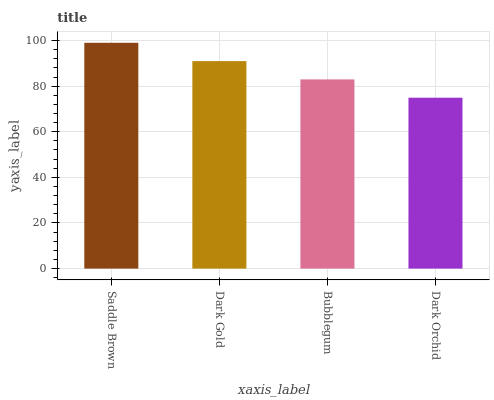Is Dark Orchid the minimum?
Answer yes or no. Yes. Is Saddle Brown the maximum?
Answer yes or no. Yes. Is Dark Gold the minimum?
Answer yes or no. No. Is Dark Gold the maximum?
Answer yes or no. No. Is Saddle Brown greater than Dark Gold?
Answer yes or no. Yes. Is Dark Gold less than Saddle Brown?
Answer yes or no. Yes. Is Dark Gold greater than Saddle Brown?
Answer yes or no. No. Is Saddle Brown less than Dark Gold?
Answer yes or no. No. Is Dark Gold the high median?
Answer yes or no. Yes. Is Bubblegum the low median?
Answer yes or no. Yes. Is Saddle Brown the high median?
Answer yes or no. No. Is Dark Orchid the low median?
Answer yes or no. No. 